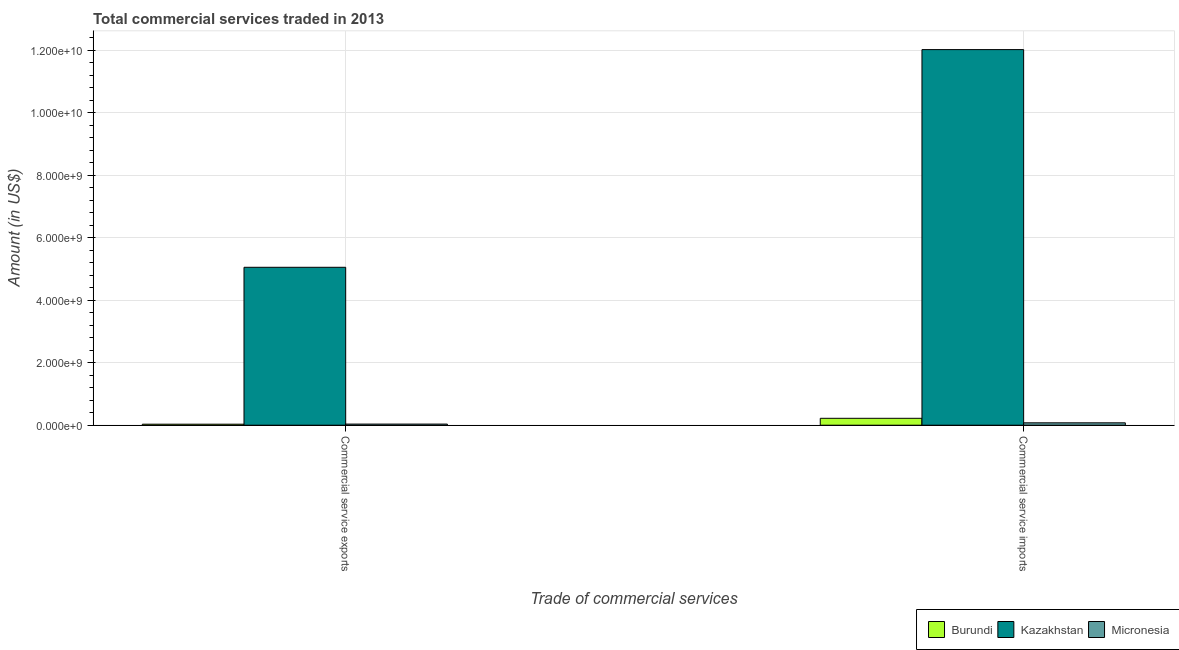How many groups of bars are there?
Your answer should be compact. 2. Are the number of bars per tick equal to the number of legend labels?
Your answer should be compact. Yes. Are the number of bars on each tick of the X-axis equal?
Keep it short and to the point. Yes. How many bars are there on the 2nd tick from the left?
Make the answer very short. 3. How many bars are there on the 1st tick from the right?
Keep it short and to the point. 3. What is the label of the 1st group of bars from the left?
Offer a terse response. Commercial service exports. What is the amount of commercial service exports in Micronesia?
Offer a very short reply. 3.59e+07. Across all countries, what is the maximum amount of commercial service exports?
Provide a succinct answer. 5.06e+09. Across all countries, what is the minimum amount of commercial service exports?
Offer a terse response. 3.23e+07. In which country was the amount of commercial service exports maximum?
Offer a terse response. Kazakhstan. In which country was the amount of commercial service exports minimum?
Offer a very short reply. Burundi. What is the total amount of commercial service imports in the graph?
Provide a succinct answer. 1.23e+1. What is the difference between the amount of commercial service imports in Kazakhstan and that in Burundi?
Offer a terse response. 1.18e+1. What is the difference between the amount of commercial service exports in Burundi and the amount of commercial service imports in Micronesia?
Offer a very short reply. -4.42e+07. What is the average amount of commercial service exports per country?
Your answer should be compact. 1.71e+09. What is the difference between the amount of commercial service imports and amount of commercial service exports in Kazakhstan?
Give a very brief answer. 6.97e+09. In how many countries, is the amount of commercial service exports greater than 4000000000 US$?
Offer a terse response. 1. What is the ratio of the amount of commercial service exports in Burundi to that in Kazakhstan?
Your response must be concise. 0.01. What does the 3rd bar from the left in Commercial service exports represents?
Provide a succinct answer. Micronesia. What does the 3rd bar from the right in Commercial service imports represents?
Keep it short and to the point. Burundi. How many bars are there?
Offer a very short reply. 6. Are all the bars in the graph horizontal?
Keep it short and to the point. No. What is the difference between two consecutive major ticks on the Y-axis?
Provide a short and direct response. 2.00e+09. Where does the legend appear in the graph?
Provide a succinct answer. Bottom right. How many legend labels are there?
Give a very brief answer. 3. What is the title of the graph?
Ensure brevity in your answer.  Total commercial services traded in 2013. What is the label or title of the X-axis?
Provide a succinct answer. Trade of commercial services. What is the label or title of the Y-axis?
Your answer should be compact. Amount (in US$). What is the Amount (in US$) of Burundi in Commercial service exports?
Keep it short and to the point. 3.23e+07. What is the Amount (in US$) in Kazakhstan in Commercial service exports?
Provide a short and direct response. 5.06e+09. What is the Amount (in US$) of Micronesia in Commercial service exports?
Keep it short and to the point. 3.59e+07. What is the Amount (in US$) of Burundi in Commercial service imports?
Keep it short and to the point. 2.21e+08. What is the Amount (in US$) of Kazakhstan in Commercial service imports?
Provide a succinct answer. 1.20e+1. What is the Amount (in US$) in Micronesia in Commercial service imports?
Keep it short and to the point. 7.65e+07. Across all Trade of commercial services, what is the maximum Amount (in US$) of Burundi?
Make the answer very short. 2.21e+08. Across all Trade of commercial services, what is the maximum Amount (in US$) in Kazakhstan?
Give a very brief answer. 1.20e+1. Across all Trade of commercial services, what is the maximum Amount (in US$) in Micronesia?
Make the answer very short. 7.65e+07. Across all Trade of commercial services, what is the minimum Amount (in US$) of Burundi?
Keep it short and to the point. 3.23e+07. Across all Trade of commercial services, what is the minimum Amount (in US$) of Kazakhstan?
Ensure brevity in your answer.  5.06e+09. Across all Trade of commercial services, what is the minimum Amount (in US$) in Micronesia?
Your response must be concise. 3.59e+07. What is the total Amount (in US$) in Burundi in the graph?
Provide a short and direct response. 2.53e+08. What is the total Amount (in US$) in Kazakhstan in the graph?
Offer a very short reply. 1.71e+1. What is the total Amount (in US$) of Micronesia in the graph?
Provide a short and direct response. 1.12e+08. What is the difference between the Amount (in US$) in Burundi in Commercial service exports and that in Commercial service imports?
Your response must be concise. -1.89e+08. What is the difference between the Amount (in US$) in Kazakhstan in Commercial service exports and that in Commercial service imports?
Provide a short and direct response. -6.97e+09. What is the difference between the Amount (in US$) of Micronesia in Commercial service exports and that in Commercial service imports?
Keep it short and to the point. -4.06e+07. What is the difference between the Amount (in US$) in Burundi in Commercial service exports and the Amount (in US$) in Kazakhstan in Commercial service imports?
Your answer should be very brief. -1.20e+1. What is the difference between the Amount (in US$) in Burundi in Commercial service exports and the Amount (in US$) in Micronesia in Commercial service imports?
Ensure brevity in your answer.  -4.42e+07. What is the difference between the Amount (in US$) in Kazakhstan in Commercial service exports and the Amount (in US$) in Micronesia in Commercial service imports?
Offer a terse response. 4.98e+09. What is the average Amount (in US$) of Burundi per Trade of commercial services?
Give a very brief answer. 1.27e+08. What is the average Amount (in US$) of Kazakhstan per Trade of commercial services?
Keep it short and to the point. 8.54e+09. What is the average Amount (in US$) of Micronesia per Trade of commercial services?
Provide a short and direct response. 5.62e+07. What is the difference between the Amount (in US$) in Burundi and Amount (in US$) in Kazakhstan in Commercial service exports?
Offer a very short reply. -5.02e+09. What is the difference between the Amount (in US$) of Burundi and Amount (in US$) of Micronesia in Commercial service exports?
Keep it short and to the point. -3.61e+06. What is the difference between the Amount (in US$) of Kazakhstan and Amount (in US$) of Micronesia in Commercial service exports?
Keep it short and to the point. 5.02e+09. What is the difference between the Amount (in US$) of Burundi and Amount (in US$) of Kazakhstan in Commercial service imports?
Make the answer very short. -1.18e+1. What is the difference between the Amount (in US$) of Burundi and Amount (in US$) of Micronesia in Commercial service imports?
Provide a succinct answer. 1.45e+08. What is the difference between the Amount (in US$) in Kazakhstan and Amount (in US$) in Micronesia in Commercial service imports?
Your answer should be very brief. 1.20e+1. What is the ratio of the Amount (in US$) in Burundi in Commercial service exports to that in Commercial service imports?
Give a very brief answer. 0.15. What is the ratio of the Amount (in US$) of Kazakhstan in Commercial service exports to that in Commercial service imports?
Make the answer very short. 0.42. What is the ratio of the Amount (in US$) in Micronesia in Commercial service exports to that in Commercial service imports?
Offer a very short reply. 0.47. What is the difference between the highest and the second highest Amount (in US$) in Burundi?
Offer a terse response. 1.89e+08. What is the difference between the highest and the second highest Amount (in US$) of Kazakhstan?
Offer a very short reply. 6.97e+09. What is the difference between the highest and the second highest Amount (in US$) in Micronesia?
Your answer should be compact. 4.06e+07. What is the difference between the highest and the lowest Amount (in US$) in Burundi?
Keep it short and to the point. 1.89e+08. What is the difference between the highest and the lowest Amount (in US$) of Kazakhstan?
Ensure brevity in your answer.  6.97e+09. What is the difference between the highest and the lowest Amount (in US$) of Micronesia?
Give a very brief answer. 4.06e+07. 